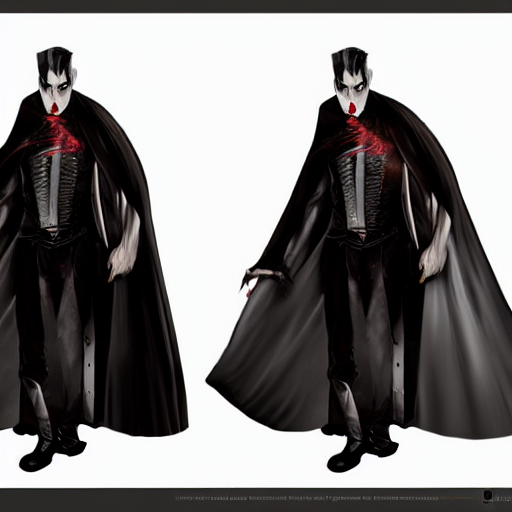How is the focus in the image?
A. Out-of-focus with noticeable noise.
B. Clear focus with no obvious noise.
C. Blurred focus with no noise.
Answer with the option's letter from the given choices directly.
 B. 